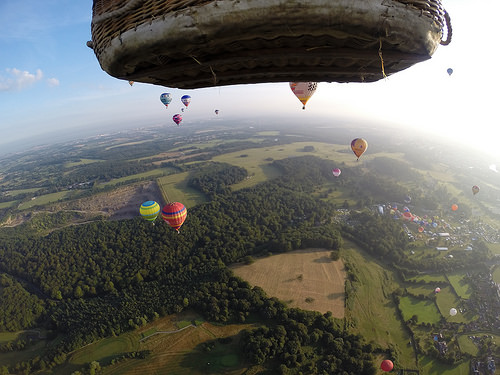<image>
Is the balloon above the trees? Yes. The balloon is positioned above the trees in the vertical space, higher up in the scene. 